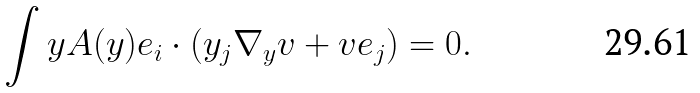Convert formula to latex. <formula><loc_0><loc_0><loc_500><loc_500>\int y { A ( y ) e _ { i } \cdot ( y _ { j } \nabla _ { y } v + v e _ { j } ) } = 0 .</formula> 